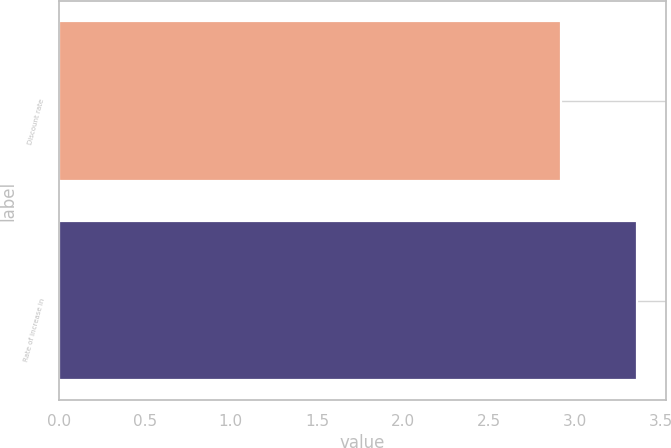<chart> <loc_0><loc_0><loc_500><loc_500><bar_chart><fcel>Discount rate<fcel>Rate of increase in<nl><fcel>2.92<fcel>3.36<nl></chart> 